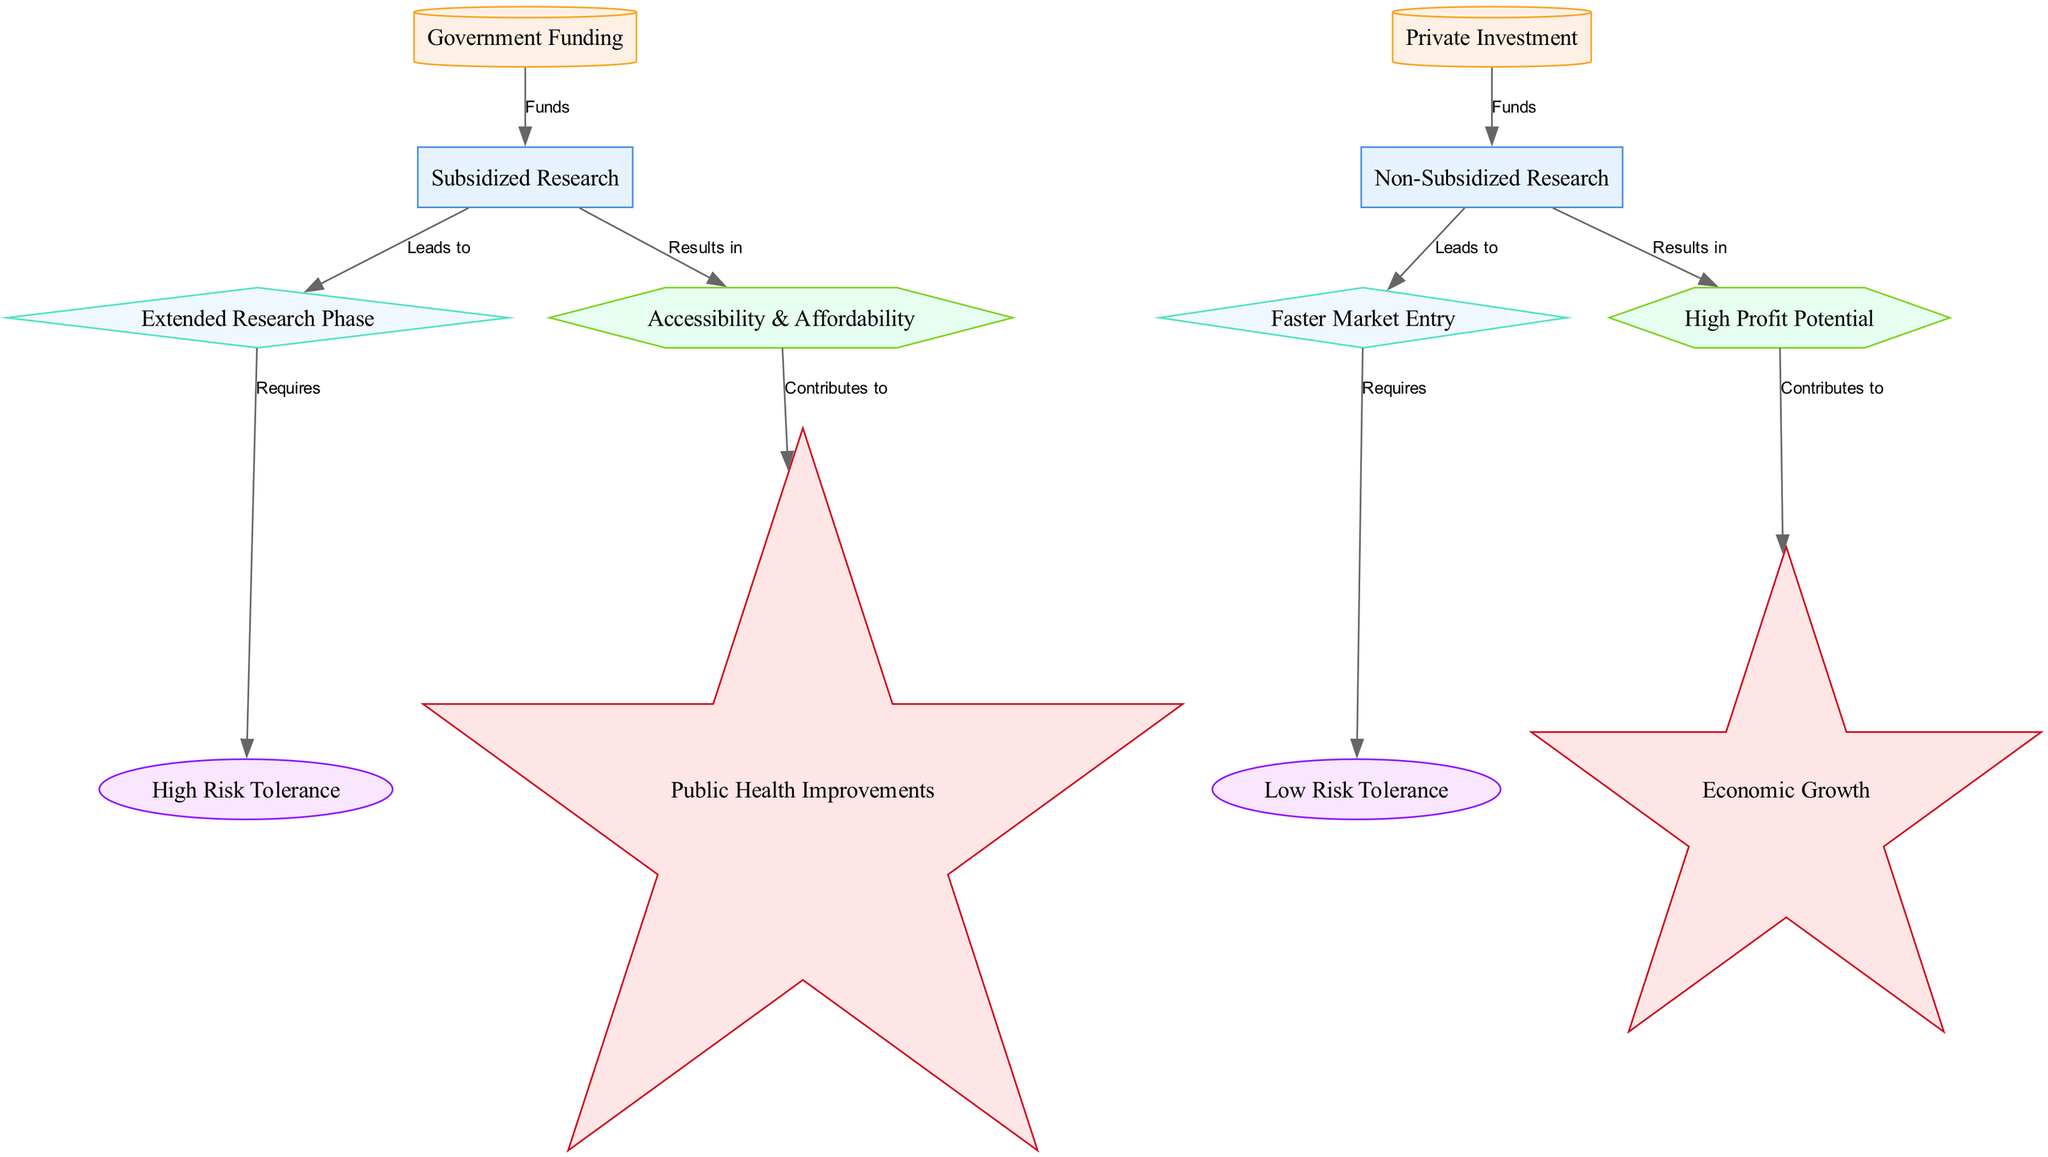What are the two types of research shown in the diagram? The diagram identifies two types of research: subsidized research and non-subsidized research. These are clearly labeled as distinct nodes within the diagram.
Answer: subsidized research, non-subsidized research How does government funding contribute to subsidized research? According to the diagram, government funding directly leads to subsidized research by providing necessary funds, illustrated by a directed edge labeled "Funds" from government funding to subsidized research.
Answer: Leads to What is the outcome of non-subsidized research? The diagram shows that non-subsidized research leads to faster market entry, which is specifically noted as an outcome in the node connected by an edge labeled "Leads to."
Answer: faster market entry Which node requires a high-risk tolerance? The extended research phase requires a high-risk tolerance, as indicated by the edge labeled “Requires” from the extended research phase to the high-risk tolerance node in the diagram.
Answer: high risk tolerance What impacts result from accessibility and affordability? The diagram illustrates that accessibility and affordability contribute to public health improvements, as shown by a connecting edge labeled "Contributes to" leading from accessibility and affordability to public health improvements.
Answer: public health improvements What is the benefit of non-subsidized research? The diagram identifies high profit potential as the benefit of non-subsidized research, represented by the directed edge leading to the high profit potential node labeled "Results in."
Answer: high profit potential How many benefits are listed in the diagram? The diagram lists two benefits: accessibility and affordability, and high profit potential. By counting the benefit nodes visually, we see there are two distinct nodes fitting this category.
Answer: 2 What does faster market entry require? The faster market entry requires low-risk tolerance, highlighted in the diagram where an edge labeled "Requires" connects faster market entry to low-risk tolerance.
Answer: low risk tolerance What type of impact does economic growth represent in the diagram? Economic growth is categorized as an impact in the diagram, which is indicated by its label and the star shape used, indicating it is an ultimate effect derived from high profit potential.
Answer: impact 